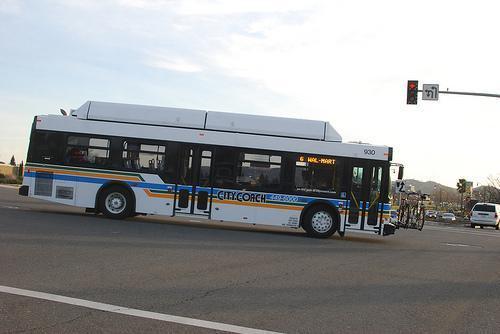How many bikes are on the bus?
Give a very brief answer. 2. 